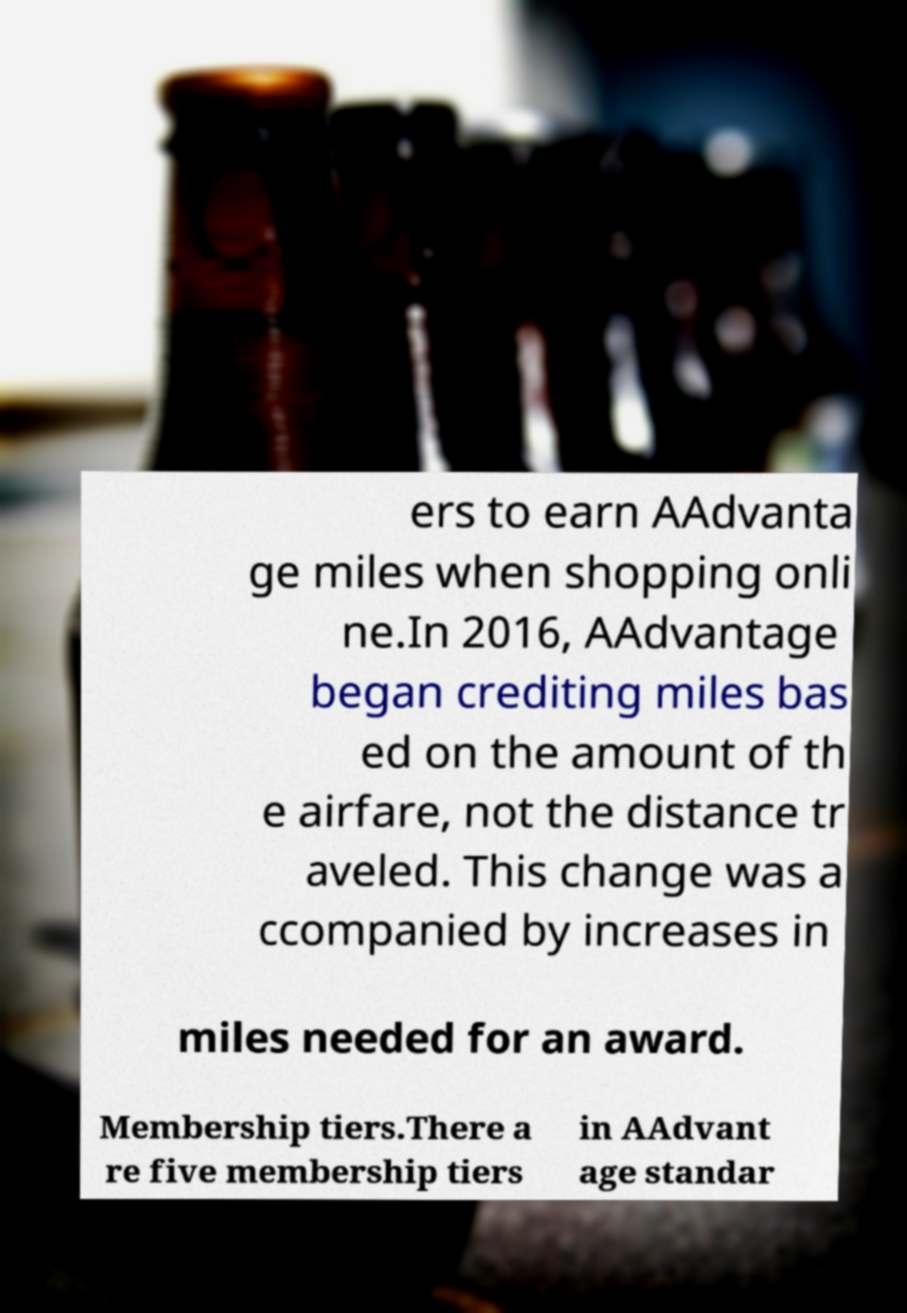There's text embedded in this image that I need extracted. Can you transcribe it verbatim? ers to earn AAdvanta ge miles when shopping onli ne.In 2016, AAdvantage began crediting miles bas ed on the amount of th e airfare, not the distance tr aveled. This change was a ccompanied by increases in miles needed for an award. Membership tiers.There a re five membership tiers in AAdvant age standar 